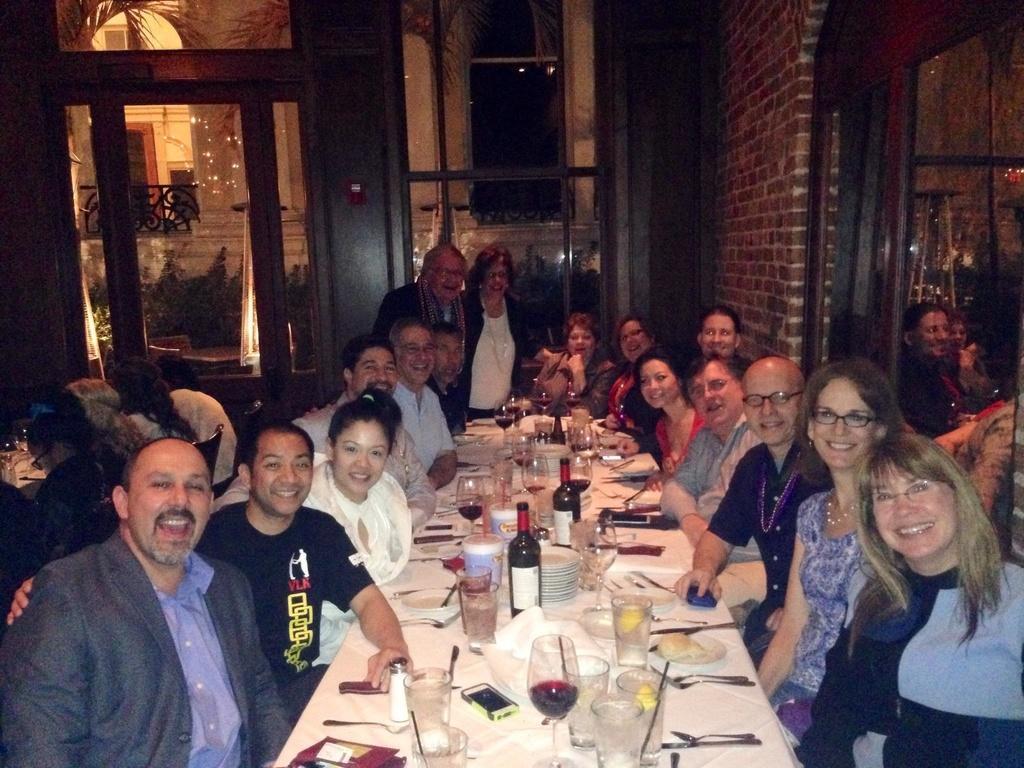Please provide a concise description of this image. There is a group of people. They are sitting on a chairs. They are smiling and some persons are wearing spectacles. In the center of the persons are standing. There is a table. There is a glass,bottle,cloth,mobile on a table. We can see in the background wall,window and plants. 